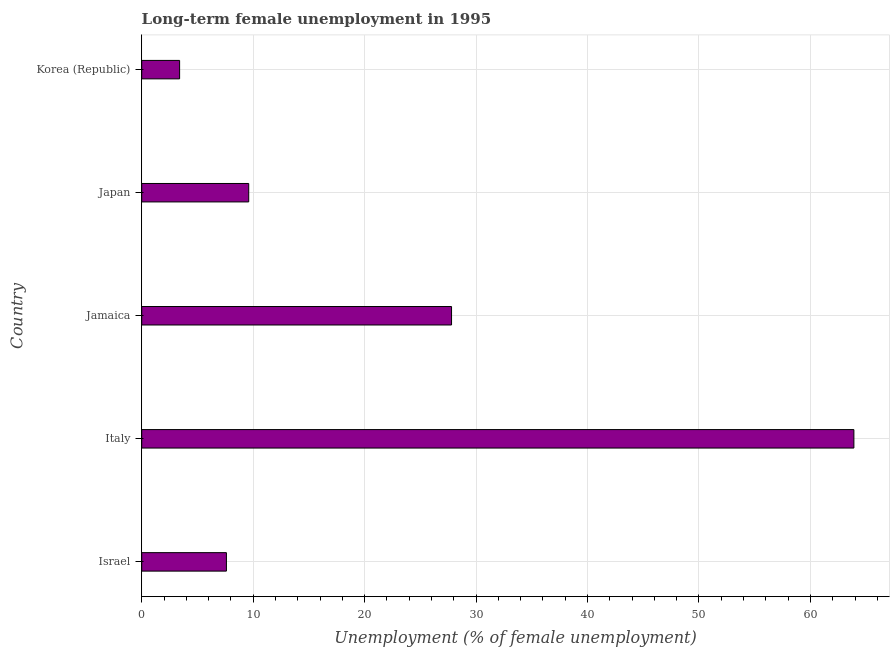Does the graph contain any zero values?
Keep it short and to the point. No. Does the graph contain grids?
Make the answer very short. Yes. What is the title of the graph?
Your response must be concise. Long-term female unemployment in 1995. What is the label or title of the X-axis?
Provide a short and direct response. Unemployment (% of female unemployment). What is the long-term female unemployment in Israel?
Provide a succinct answer. 7.6. Across all countries, what is the maximum long-term female unemployment?
Your response must be concise. 63.9. Across all countries, what is the minimum long-term female unemployment?
Your answer should be compact. 3.4. In which country was the long-term female unemployment minimum?
Offer a terse response. Korea (Republic). What is the sum of the long-term female unemployment?
Ensure brevity in your answer.  112.3. What is the average long-term female unemployment per country?
Offer a very short reply. 22.46. What is the median long-term female unemployment?
Make the answer very short. 9.6. In how many countries, is the long-term female unemployment greater than 36 %?
Keep it short and to the point. 1. What is the ratio of the long-term female unemployment in Japan to that in Korea (Republic)?
Provide a succinct answer. 2.82. Is the long-term female unemployment in Italy less than that in Jamaica?
Your answer should be compact. No. Is the difference between the long-term female unemployment in Jamaica and Korea (Republic) greater than the difference between any two countries?
Offer a very short reply. No. What is the difference between the highest and the second highest long-term female unemployment?
Your answer should be very brief. 36.1. What is the difference between the highest and the lowest long-term female unemployment?
Ensure brevity in your answer.  60.5. In how many countries, is the long-term female unemployment greater than the average long-term female unemployment taken over all countries?
Keep it short and to the point. 2. Are all the bars in the graph horizontal?
Your answer should be compact. Yes. Are the values on the major ticks of X-axis written in scientific E-notation?
Ensure brevity in your answer.  No. What is the Unemployment (% of female unemployment) of Israel?
Provide a succinct answer. 7.6. What is the Unemployment (% of female unemployment) of Italy?
Your answer should be very brief. 63.9. What is the Unemployment (% of female unemployment) in Jamaica?
Keep it short and to the point. 27.8. What is the Unemployment (% of female unemployment) of Japan?
Provide a succinct answer. 9.6. What is the Unemployment (% of female unemployment) in Korea (Republic)?
Offer a terse response. 3.4. What is the difference between the Unemployment (% of female unemployment) in Israel and Italy?
Your answer should be very brief. -56.3. What is the difference between the Unemployment (% of female unemployment) in Israel and Jamaica?
Offer a terse response. -20.2. What is the difference between the Unemployment (% of female unemployment) in Israel and Japan?
Provide a short and direct response. -2. What is the difference between the Unemployment (% of female unemployment) in Israel and Korea (Republic)?
Your answer should be very brief. 4.2. What is the difference between the Unemployment (% of female unemployment) in Italy and Jamaica?
Provide a succinct answer. 36.1. What is the difference between the Unemployment (% of female unemployment) in Italy and Japan?
Offer a terse response. 54.3. What is the difference between the Unemployment (% of female unemployment) in Italy and Korea (Republic)?
Ensure brevity in your answer.  60.5. What is the difference between the Unemployment (% of female unemployment) in Jamaica and Korea (Republic)?
Provide a short and direct response. 24.4. What is the ratio of the Unemployment (% of female unemployment) in Israel to that in Italy?
Offer a very short reply. 0.12. What is the ratio of the Unemployment (% of female unemployment) in Israel to that in Jamaica?
Your response must be concise. 0.27. What is the ratio of the Unemployment (% of female unemployment) in Israel to that in Japan?
Make the answer very short. 0.79. What is the ratio of the Unemployment (% of female unemployment) in Israel to that in Korea (Republic)?
Give a very brief answer. 2.23. What is the ratio of the Unemployment (% of female unemployment) in Italy to that in Jamaica?
Ensure brevity in your answer.  2.3. What is the ratio of the Unemployment (% of female unemployment) in Italy to that in Japan?
Your answer should be compact. 6.66. What is the ratio of the Unemployment (% of female unemployment) in Italy to that in Korea (Republic)?
Keep it short and to the point. 18.79. What is the ratio of the Unemployment (% of female unemployment) in Jamaica to that in Japan?
Offer a terse response. 2.9. What is the ratio of the Unemployment (% of female unemployment) in Jamaica to that in Korea (Republic)?
Give a very brief answer. 8.18. What is the ratio of the Unemployment (% of female unemployment) in Japan to that in Korea (Republic)?
Provide a short and direct response. 2.82. 